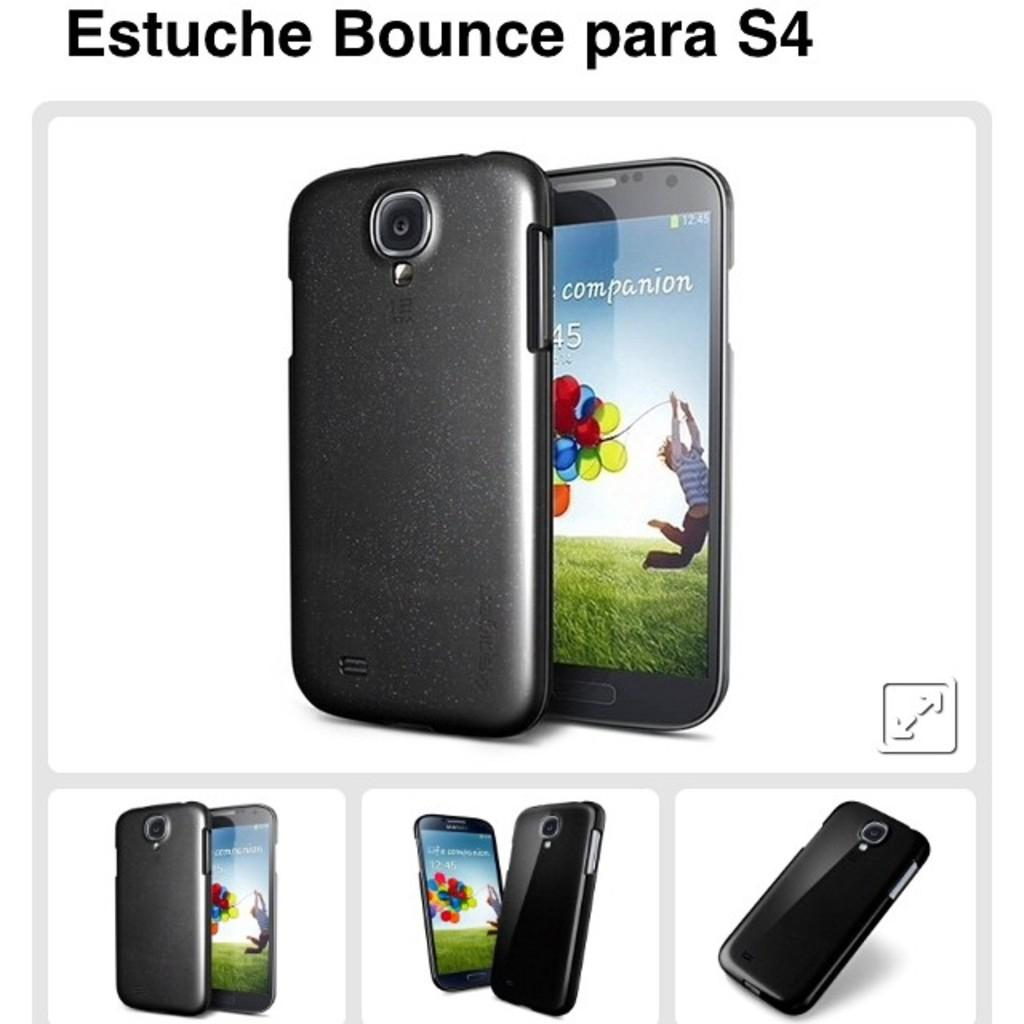<image>
Write a terse but informative summary of the picture. A phone with the word "companion" on the screen shows a child with a bunch of balloons. 